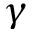Convert formula to latex. <formula><loc_0><loc_0><loc_500><loc_500>\gamma</formula> 